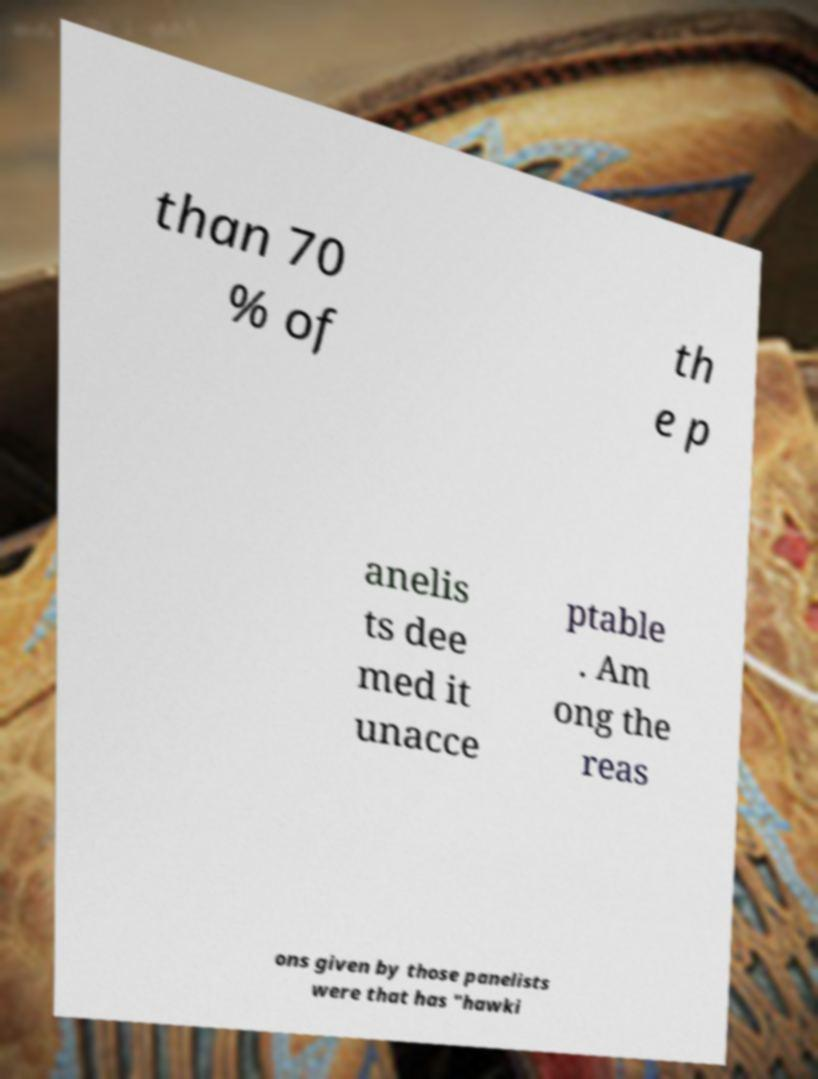Could you extract and type out the text from this image? than 70 % of th e p anelis ts dee med it unacce ptable . Am ong the reas ons given by those panelists were that has "hawki 